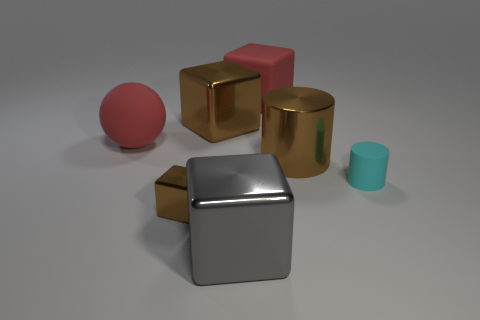Add 3 red rubber things. How many objects exist? 10 Subtract all red cubes. How many cubes are left? 3 Subtract all big cubes. How many cubes are left? 1 Subtract all cyan blocks. Subtract all brown balls. How many blocks are left? 4 Subtract all cylinders. How many objects are left? 5 Subtract all small red metallic cylinders. Subtract all cyan cylinders. How many objects are left? 6 Add 7 large red rubber things. How many large red rubber things are left? 9 Add 1 large blue shiny cylinders. How many large blue shiny cylinders exist? 1 Subtract 0 purple cylinders. How many objects are left? 7 